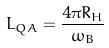Convert formula to latex. <formula><loc_0><loc_0><loc_500><loc_500>L _ { Q A } = \frac { 4 \pi R _ { H } } { \omega _ { B } }</formula> 